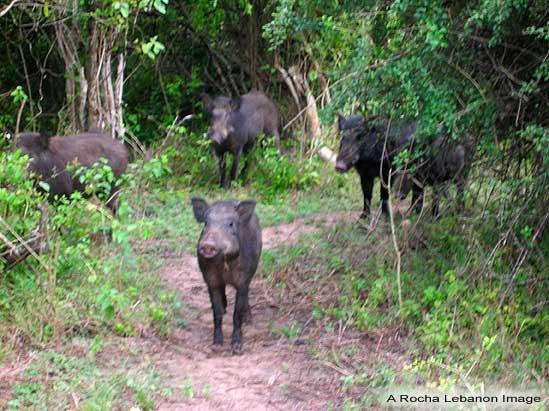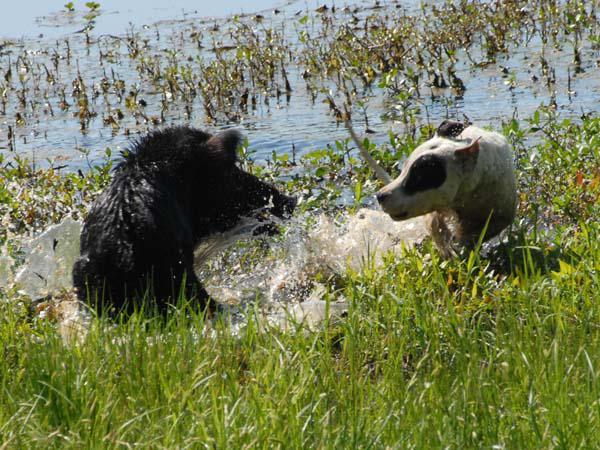The first image is the image on the left, the second image is the image on the right. For the images shown, is this caption "On one image features one dog near a pig." true? Answer yes or no. Yes. 